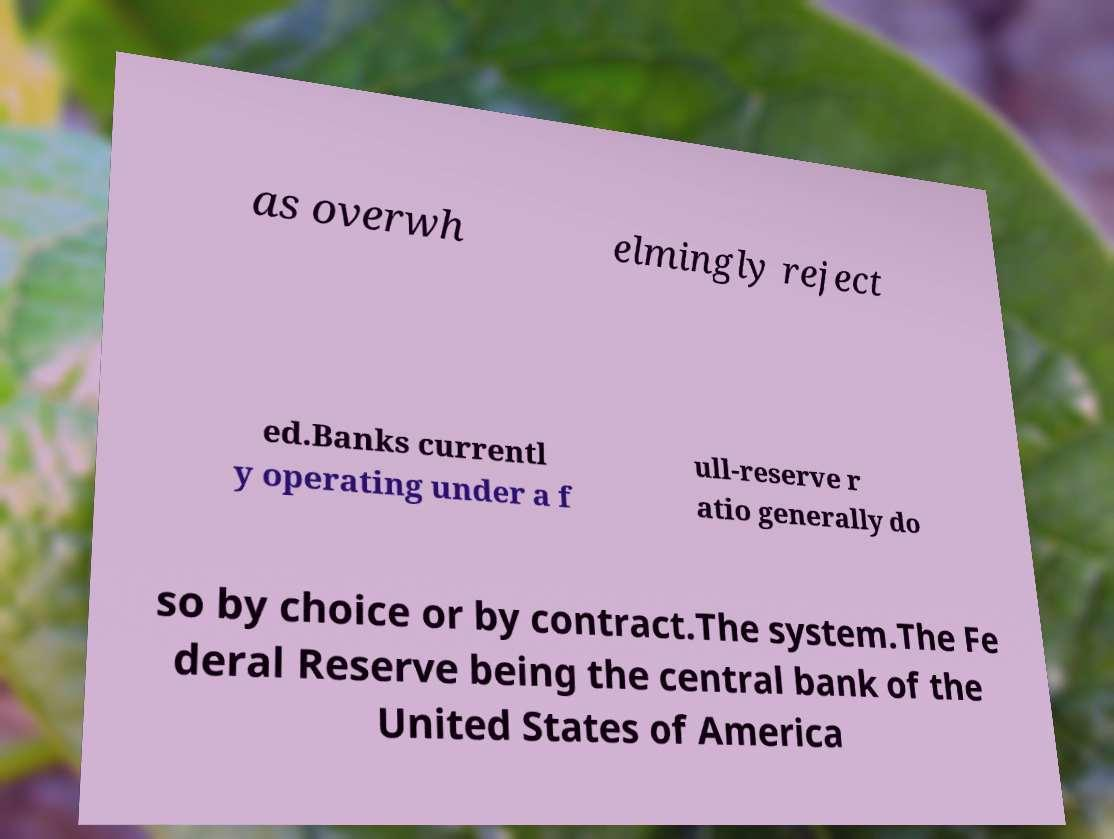Can you accurately transcribe the text from the provided image for me? as overwh elmingly reject ed.Banks currentl y operating under a f ull-reserve r atio generally do so by choice or by contract.The system.The Fe deral Reserve being the central bank of the United States of America 